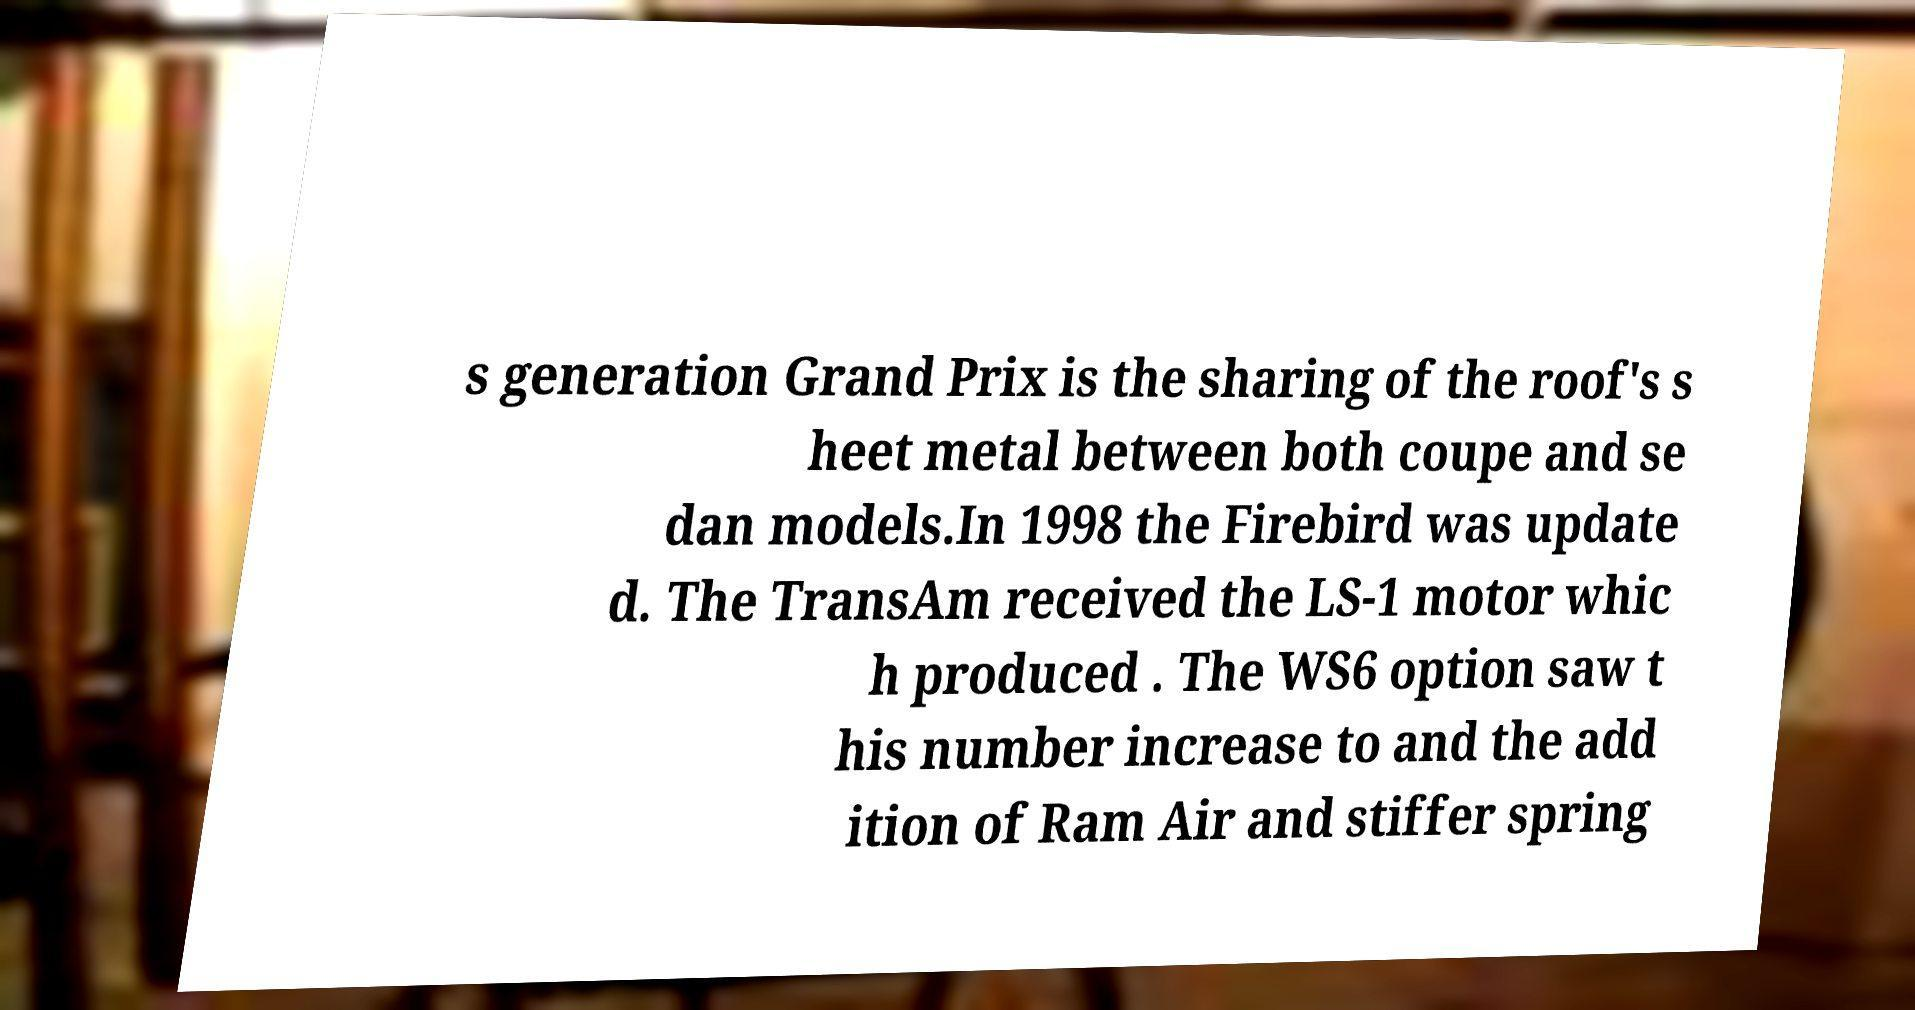There's text embedded in this image that I need extracted. Can you transcribe it verbatim? s generation Grand Prix is the sharing of the roof's s heet metal between both coupe and se dan models.In 1998 the Firebird was update d. The TransAm received the LS-1 motor whic h produced . The WS6 option saw t his number increase to and the add ition of Ram Air and stiffer spring 